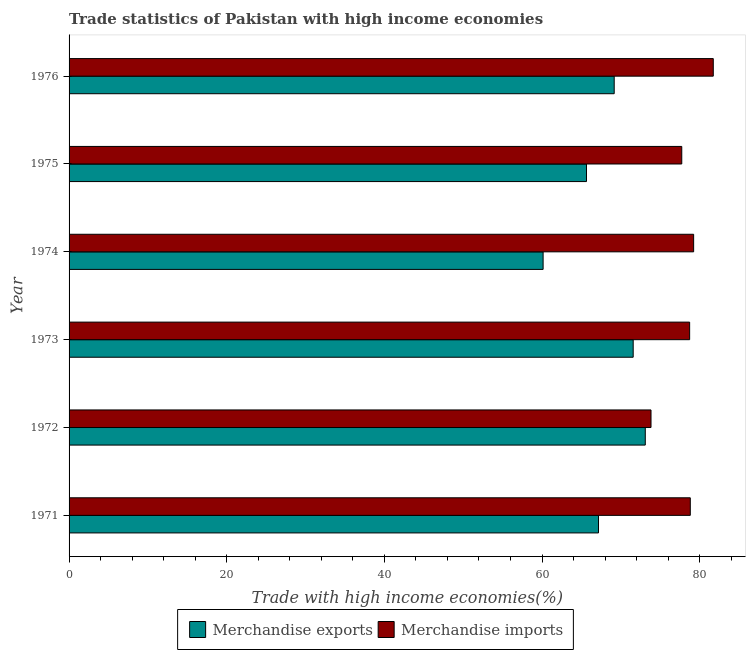How many different coloured bars are there?
Offer a very short reply. 2. Are the number of bars per tick equal to the number of legend labels?
Give a very brief answer. Yes. Are the number of bars on each tick of the Y-axis equal?
Ensure brevity in your answer.  Yes. How many bars are there on the 3rd tick from the bottom?
Keep it short and to the point. 2. What is the label of the 3rd group of bars from the top?
Offer a terse response. 1974. In how many cases, is the number of bars for a given year not equal to the number of legend labels?
Keep it short and to the point. 0. What is the merchandise imports in 1973?
Ensure brevity in your answer.  78.73. Across all years, what is the maximum merchandise imports?
Give a very brief answer. 81.73. Across all years, what is the minimum merchandise exports?
Offer a terse response. 60.14. In which year was the merchandise exports maximum?
Offer a very short reply. 1972. In which year was the merchandise exports minimum?
Your response must be concise. 1974. What is the total merchandise imports in the graph?
Provide a short and direct response. 470.07. What is the difference between the merchandise exports in 1971 and that in 1975?
Your response must be concise. 1.52. What is the difference between the merchandise imports in 1975 and the merchandise exports in 1971?
Provide a short and direct response. 10.56. What is the average merchandise exports per year?
Offer a terse response. 67.8. In the year 1973, what is the difference between the merchandise exports and merchandise imports?
Keep it short and to the point. -7.16. In how many years, is the merchandise exports greater than 36 %?
Your answer should be very brief. 6. What is the difference between the highest and the second highest merchandise exports?
Provide a succinct answer. 1.53. What is the difference between the highest and the lowest merchandise imports?
Provide a succinct answer. 7.9. In how many years, is the merchandise imports greater than the average merchandise imports taken over all years?
Make the answer very short. 4. Is the sum of the merchandise exports in 1971 and 1972 greater than the maximum merchandise imports across all years?
Offer a very short reply. Yes. Does the graph contain any zero values?
Ensure brevity in your answer.  No. Does the graph contain grids?
Your answer should be very brief. No. What is the title of the graph?
Offer a terse response. Trade statistics of Pakistan with high income economies. What is the label or title of the X-axis?
Offer a very short reply. Trade with high income economies(%). What is the label or title of the Y-axis?
Ensure brevity in your answer.  Year. What is the Trade with high income economies(%) of Merchandise exports in 1971?
Your response must be concise. 67.17. What is the Trade with high income economies(%) in Merchandise imports in 1971?
Keep it short and to the point. 78.81. What is the Trade with high income economies(%) in Merchandise exports in 1972?
Your answer should be compact. 73.1. What is the Trade with high income economies(%) of Merchandise imports in 1972?
Your response must be concise. 73.83. What is the Trade with high income economies(%) in Merchandise exports in 1973?
Provide a succinct answer. 71.57. What is the Trade with high income economies(%) of Merchandise imports in 1973?
Your answer should be compact. 78.73. What is the Trade with high income economies(%) in Merchandise exports in 1974?
Offer a very short reply. 60.14. What is the Trade with high income economies(%) in Merchandise imports in 1974?
Your response must be concise. 79.24. What is the Trade with high income economies(%) in Merchandise exports in 1975?
Offer a very short reply. 65.64. What is the Trade with high income economies(%) in Merchandise imports in 1975?
Give a very brief answer. 77.73. What is the Trade with high income economies(%) in Merchandise exports in 1976?
Give a very brief answer. 69.16. What is the Trade with high income economies(%) of Merchandise imports in 1976?
Keep it short and to the point. 81.73. Across all years, what is the maximum Trade with high income economies(%) of Merchandise exports?
Your answer should be very brief. 73.1. Across all years, what is the maximum Trade with high income economies(%) in Merchandise imports?
Your answer should be compact. 81.73. Across all years, what is the minimum Trade with high income economies(%) of Merchandise exports?
Offer a terse response. 60.14. Across all years, what is the minimum Trade with high income economies(%) of Merchandise imports?
Make the answer very short. 73.83. What is the total Trade with high income economies(%) of Merchandise exports in the graph?
Give a very brief answer. 406.79. What is the total Trade with high income economies(%) in Merchandise imports in the graph?
Ensure brevity in your answer.  470.07. What is the difference between the Trade with high income economies(%) of Merchandise exports in 1971 and that in 1972?
Your answer should be very brief. -5.93. What is the difference between the Trade with high income economies(%) in Merchandise imports in 1971 and that in 1972?
Provide a short and direct response. 4.98. What is the difference between the Trade with high income economies(%) of Merchandise exports in 1971 and that in 1973?
Your answer should be compact. -4.4. What is the difference between the Trade with high income economies(%) in Merchandise imports in 1971 and that in 1973?
Give a very brief answer. 0.08. What is the difference between the Trade with high income economies(%) in Merchandise exports in 1971 and that in 1974?
Your answer should be very brief. 7.03. What is the difference between the Trade with high income economies(%) in Merchandise imports in 1971 and that in 1974?
Keep it short and to the point. -0.43. What is the difference between the Trade with high income economies(%) in Merchandise exports in 1971 and that in 1975?
Your answer should be compact. 1.52. What is the difference between the Trade with high income economies(%) of Merchandise imports in 1971 and that in 1975?
Keep it short and to the point. 1.08. What is the difference between the Trade with high income economies(%) of Merchandise exports in 1971 and that in 1976?
Your answer should be very brief. -1.99. What is the difference between the Trade with high income economies(%) in Merchandise imports in 1971 and that in 1976?
Your response must be concise. -2.92. What is the difference between the Trade with high income economies(%) in Merchandise exports in 1972 and that in 1973?
Offer a terse response. 1.53. What is the difference between the Trade with high income economies(%) of Merchandise imports in 1972 and that in 1973?
Offer a very short reply. -4.9. What is the difference between the Trade with high income economies(%) of Merchandise exports in 1972 and that in 1974?
Provide a short and direct response. 12.96. What is the difference between the Trade with high income economies(%) of Merchandise imports in 1972 and that in 1974?
Keep it short and to the point. -5.41. What is the difference between the Trade with high income economies(%) in Merchandise exports in 1972 and that in 1975?
Offer a terse response. 7.46. What is the difference between the Trade with high income economies(%) of Merchandise imports in 1972 and that in 1975?
Keep it short and to the point. -3.9. What is the difference between the Trade with high income economies(%) in Merchandise exports in 1972 and that in 1976?
Provide a succinct answer. 3.94. What is the difference between the Trade with high income economies(%) in Merchandise imports in 1972 and that in 1976?
Provide a succinct answer. -7.9. What is the difference between the Trade with high income economies(%) of Merchandise exports in 1973 and that in 1974?
Your answer should be very brief. 11.43. What is the difference between the Trade with high income economies(%) of Merchandise imports in 1973 and that in 1974?
Provide a succinct answer. -0.51. What is the difference between the Trade with high income economies(%) of Merchandise exports in 1973 and that in 1975?
Offer a very short reply. 5.92. What is the difference between the Trade with high income economies(%) of Merchandise exports in 1973 and that in 1976?
Your response must be concise. 2.41. What is the difference between the Trade with high income economies(%) in Merchandise imports in 1973 and that in 1976?
Your answer should be very brief. -3. What is the difference between the Trade with high income economies(%) in Merchandise exports in 1974 and that in 1975?
Your answer should be compact. -5.5. What is the difference between the Trade with high income economies(%) of Merchandise imports in 1974 and that in 1975?
Keep it short and to the point. 1.51. What is the difference between the Trade with high income economies(%) of Merchandise exports in 1974 and that in 1976?
Your answer should be very brief. -9.02. What is the difference between the Trade with high income economies(%) in Merchandise imports in 1974 and that in 1976?
Give a very brief answer. -2.49. What is the difference between the Trade with high income economies(%) of Merchandise exports in 1975 and that in 1976?
Ensure brevity in your answer.  -3.51. What is the difference between the Trade with high income economies(%) of Merchandise imports in 1975 and that in 1976?
Your answer should be compact. -4. What is the difference between the Trade with high income economies(%) of Merchandise exports in 1971 and the Trade with high income economies(%) of Merchandise imports in 1972?
Ensure brevity in your answer.  -6.66. What is the difference between the Trade with high income economies(%) in Merchandise exports in 1971 and the Trade with high income economies(%) in Merchandise imports in 1973?
Ensure brevity in your answer.  -11.56. What is the difference between the Trade with high income economies(%) of Merchandise exports in 1971 and the Trade with high income economies(%) of Merchandise imports in 1974?
Your answer should be compact. -12.07. What is the difference between the Trade with high income economies(%) in Merchandise exports in 1971 and the Trade with high income economies(%) in Merchandise imports in 1975?
Give a very brief answer. -10.56. What is the difference between the Trade with high income economies(%) of Merchandise exports in 1971 and the Trade with high income economies(%) of Merchandise imports in 1976?
Offer a terse response. -14.56. What is the difference between the Trade with high income economies(%) in Merchandise exports in 1972 and the Trade with high income economies(%) in Merchandise imports in 1973?
Offer a very short reply. -5.63. What is the difference between the Trade with high income economies(%) in Merchandise exports in 1972 and the Trade with high income economies(%) in Merchandise imports in 1974?
Offer a very short reply. -6.14. What is the difference between the Trade with high income economies(%) in Merchandise exports in 1972 and the Trade with high income economies(%) in Merchandise imports in 1975?
Ensure brevity in your answer.  -4.63. What is the difference between the Trade with high income economies(%) of Merchandise exports in 1972 and the Trade with high income economies(%) of Merchandise imports in 1976?
Offer a very short reply. -8.63. What is the difference between the Trade with high income economies(%) in Merchandise exports in 1973 and the Trade with high income economies(%) in Merchandise imports in 1974?
Provide a succinct answer. -7.67. What is the difference between the Trade with high income economies(%) of Merchandise exports in 1973 and the Trade with high income economies(%) of Merchandise imports in 1975?
Ensure brevity in your answer.  -6.16. What is the difference between the Trade with high income economies(%) of Merchandise exports in 1973 and the Trade with high income economies(%) of Merchandise imports in 1976?
Offer a very short reply. -10.16. What is the difference between the Trade with high income economies(%) of Merchandise exports in 1974 and the Trade with high income economies(%) of Merchandise imports in 1975?
Keep it short and to the point. -17.59. What is the difference between the Trade with high income economies(%) in Merchandise exports in 1974 and the Trade with high income economies(%) in Merchandise imports in 1976?
Keep it short and to the point. -21.59. What is the difference between the Trade with high income economies(%) in Merchandise exports in 1975 and the Trade with high income economies(%) in Merchandise imports in 1976?
Keep it short and to the point. -16.09. What is the average Trade with high income economies(%) of Merchandise exports per year?
Offer a very short reply. 67.8. What is the average Trade with high income economies(%) of Merchandise imports per year?
Offer a very short reply. 78.35. In the year 1971, what is the difference between the Trade with high income economies(%) of Merchandise exports and Trade with high income economies(%) of Merchandise imports?
Offer a very short reply. -11.65. In the year 1972, what is the difference between the Trade with high income economies(%) in Merchandise exports and Trade with high income economies(%) in Merchandise imports?
Your response must be concise. -0.73. In the year 1973, what is the difference between the Trade with high income economies(%) of Merchandise exports and Trade with high income economies(%) of Merchandise imports?
Keep it short and to the point. -7.16. In the year 1974, what is the difference between the Trade with high income economies(%) of Merchandise exports and Trade with high income economies(%) of Merchandise imports?
Keep it short and to the point. -19.1. In the year 1975, what is the difference between the Trade with high income economies(%) in Merchandise exports and Trade with high income economies(%) in Merchandise imports?
Give a very brief answer. -12.09. In the year 1976, what is the difference between the Trade with high income economies(%) in Merchandise exports and Trade with high income economies(%) in Merchandise imports?
Give a very brief answer. -12.57. What is the ratio of the Trade with high income economies(%) of Merchandise exports in 1971 to that in 1972?
Provide a succinct answer. 0.92. What is the ratio of the Trade with high income economies(%) of Merchandise imports in 1971 to that in 1972?
Offer a terse response. 1.07. What is the ratio of the Trade with high income economies(%) of Merchandise exports in 1971 to that in 1973?
Offer a terse response. 0.94. What is the ratio of the Trade with high income economies(%) in Merchandise imports in 1971 to that in 1973?
Keep it short and to the point. 1. What is the ratio of the Trade with high income economies(%) of Merchandise exports in 1971 to that in 1974?
Provide a succinct answer. 1.12. What is the ratio of the Trade with high income economies(%) of Merchandise imports in 1971 to that in 1974?
Ensure brevity in your answer.  0.99. What is the ratio of the Trade with high income economies(%) of Merchandise exports in 1971 to that in 1975?
Your answer should be compact. 1.02. What is the ratio of the Trade with high income economies(%) of Merchandise imports in 1971 to that in 1975?
Keep it short and to the point. 1.01. What is the ratio of the Trade with high income economies(%) in Merchandise exports in 1971 to that in 1976?
Your answer should be compact. 0.97. What is the ratio of the Trade with high income economies(%) of Merchandise exports in 1972 to that in 1973?
Offer a terse response. 1.02. What is the ratio of the Trade with high income economies(%) in Merchandise imports in 1972 to that in 1973?
Provide a succinct answer. 0.94. What is the ratio of the Trade with high income economies(%) in Merchandise exports in 1972 to that in 1974?
Your answer should be compact. 1.22. What is the ratio of the Trade with high income economies(%) in Merchandise imports in 1972 to that in 1974?
Offer a very short reply. 0.93. What is the ratio of the Trade with high income economies(%) of Merchandise exports in 1972 to that in 1975?
Your answer should be compact. 1.11. What is the ratio of the Trade with high income economies(%) of Merchandise imports in 1972 to that in 1975?
Offer a very short reply. 0.95. What is the ratio of the Trade with high income economies(%) in Merchandise exports in 1972 to that in 1976?
Offer a terse response. 1.06. What is the ratio of the Trade with high income economies(%) in Merchandise imports in 1972 to that in 1976?
Give a very brief answer. 0.9. What is the ratio of the Trade with high income economies(%) in Merchandise exports in 1973 to that in 1974?
Provide a succinct answer. 1.19. What is the ratio of the Trade with high income economies(%) in Merchandise exports in 1973 to that in 1975?
Provide a short and direct response. 1.09. What is the ratio of the Trade with high income economies(%) in Merchandise imports in 1973 to that in 1975?
Offer a very short reply. 1.01. What is the ratio of the Trade with high income economies(%) in Merchandise exports in 1973 to that in 1976?
Provide a succinct answer. 1.03. What is the ratio of the Trade with high income economies(%) in Merchandise imports in 1973 to that in 1976?
Make the answer very short. 0.96. What is the ratio of the Trade with high income economies(%) of Merchandise exports in 1974 to that in 1975?
Keep it short and to the point. 0.92. What is the ratio of the Trade with high income economies(%) of Merchandise imports in 1974 to that in 1975?
Make the answer very short. 1.02. What is the ratio of the Trade with high income economies(%) in Merchandise exports in 1974 to that in 1976?
Make the answer very short. 0.87. What is the ratio of the Trade with high income economies(%) of Merchandise imports in 1974 to that in 1976?
Offer a terse response. 0.97. What is the ratio of the Trade with high income economies(%) in Merchandise exports in 1975 to that in 1976?
Make the answer very short. 0.95. What is the ratio of the Trade with high income economies(%) of Merchandise imports in 1975 to that in 1976?
Make the answer very short. 0.95. What is the difference between the highest and the second highest Trade with high income economies(%) in Merchandise exports?
Your answer should be compact. 1.53. What is the difference between the highest and the second highest Trade with high income economies(%) in Merchandise imports?
Offer a very short reply. 2.49. What is the difference between the highest and the lowest Trade with high income economies(%) in Merchandise exports?
Keep it short and to the point. 12.96. What is the difference between the highest and the lowest Trade with high income economies(%) of Merchandise imports?
Give a very brief answer. 7.9. 